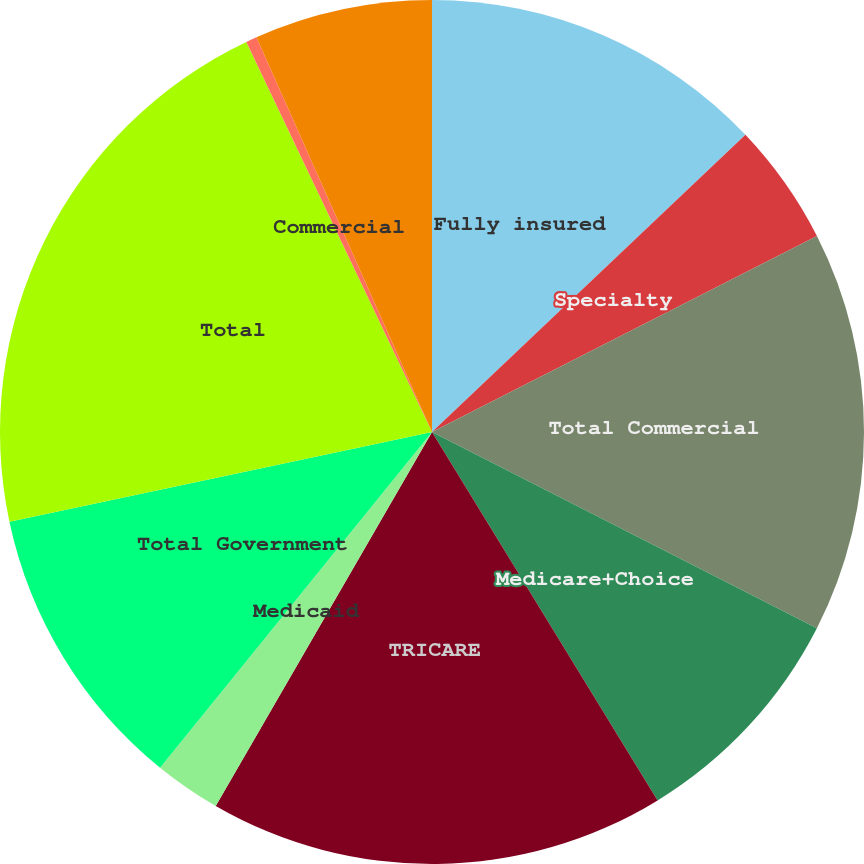Convert chart. <chart><loc_0><loc_0><loc_500><loc_500><pie_chart><fcel>Fully insured<fcel>Specialty<fcel>Total Commercial<fcel>Medicare+Choice<fcel>TRICARE<fcel>Medicaid<fcel>Total Government<fcel>Total<fcel>Commercial<fcel>Government<nl><fcel>12.92%<fcel>4.58%<fcel>15.0%<fcel>8.75%<fcel>17.09%<fcel>2.49%<fcel>10.83%<fcel>21.26%<fcel>0.41%<fcel>6.66%<nl></chart> 